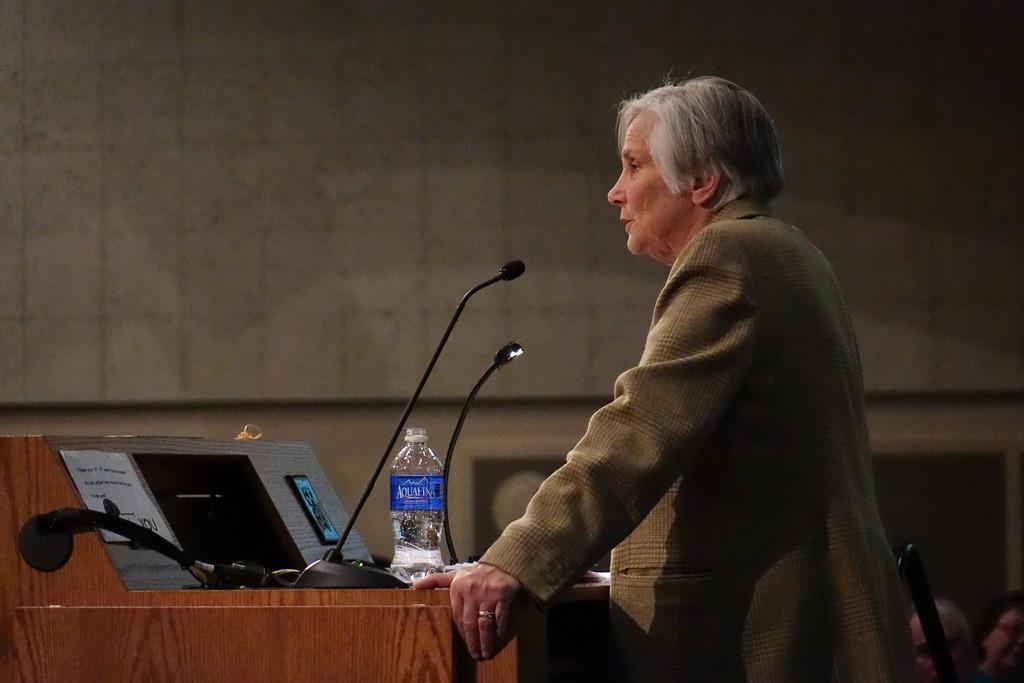How would you summarize this image in a sentence or two? There is a person standing in the foreground area of the image, there are mice, bottle and other objects on the desk. 